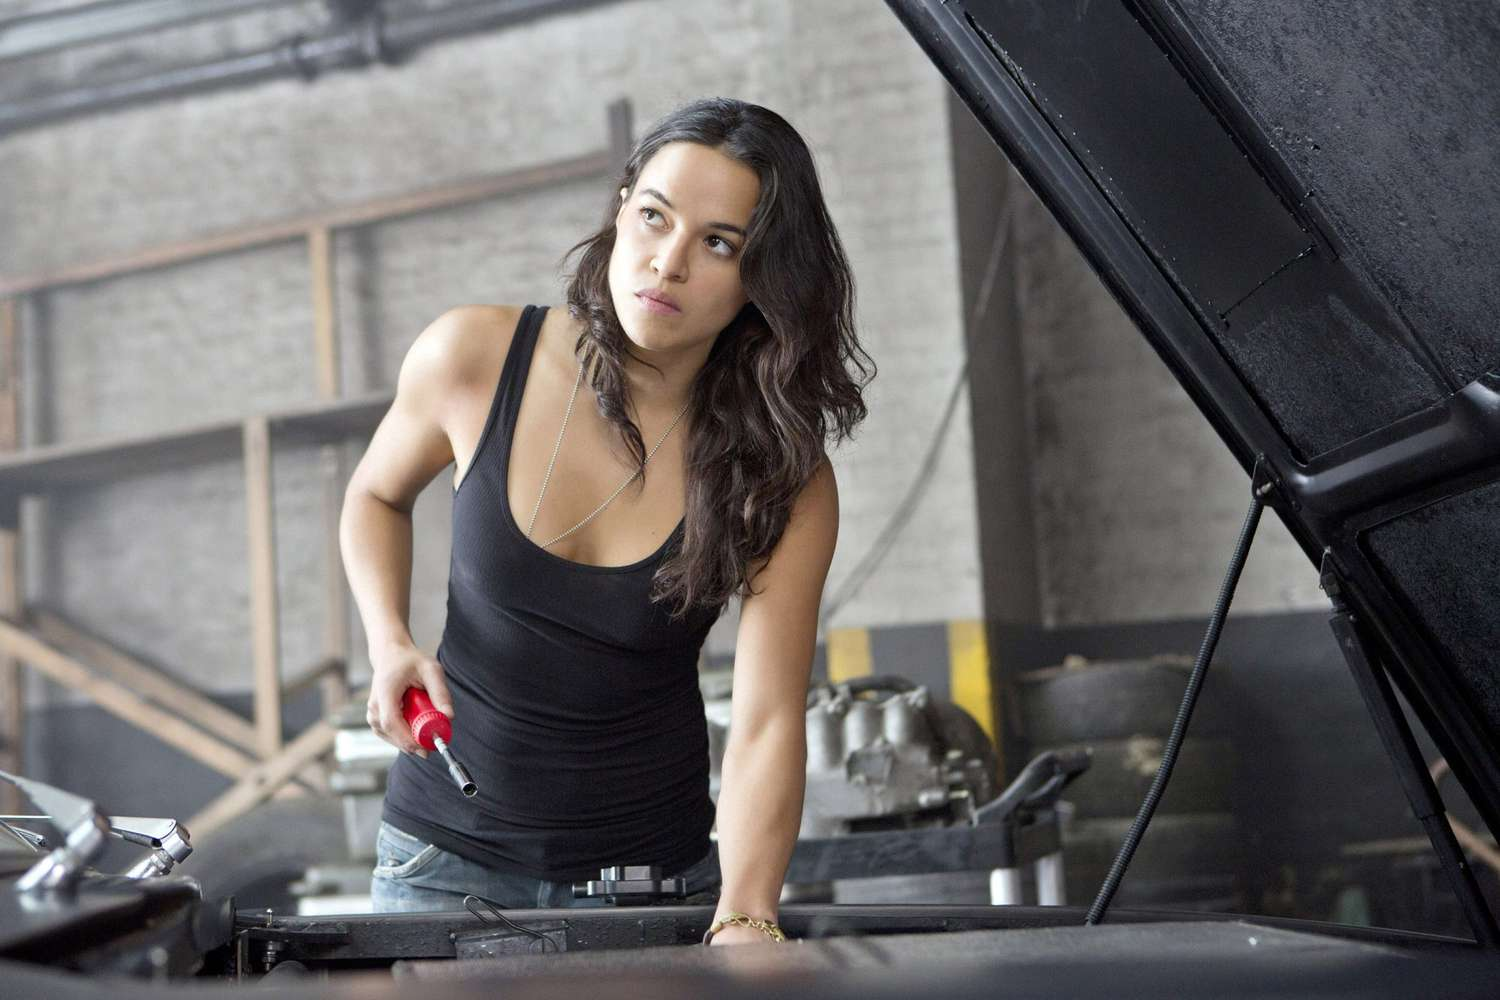Describe the surroundings and environment of the image. The image is set in what appears to be a well-used garage. The background features shelving with wooden supports, suggesting a space built for heavy, practical work rather than appearance. Various car parts and tools are visible, including tires and industrial equipment, painting a picture of a fully functioning workshop. The lighting is ambient, likely natural, bouncing off the pale, slightly worn walls. This environment gives a sense of authenticity and hard work, where vehicle maintenance and repair take center stage. 